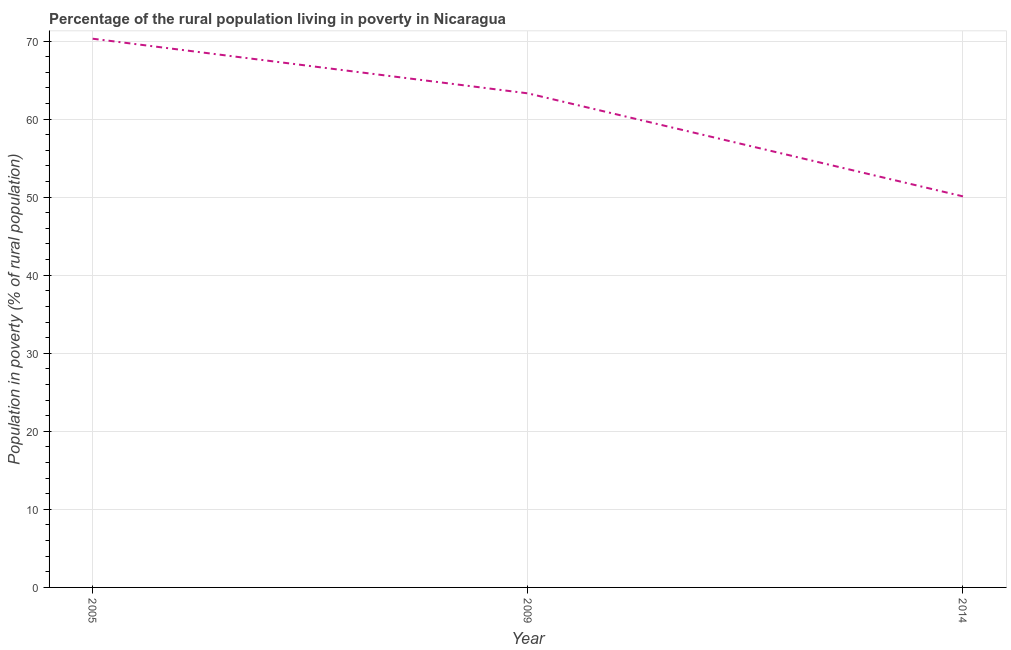What is the percentage of rural population living below poverty line in 2014?
Ensure brevity in your answer.  50.1. Across all years, what is the maximum percentage of rural population living below poverty line?
Your answer should be very brief. 70.3. Across all years, what is the minimum percentage of rural population living below poverty line?
Give a very brief answer. 50.1. In which year was the percentage of rural population living below poverty line minimum?
Keep it short and to the point. 2014. What is the sum of the percentage of rural population living below poverty line?
Provide a short and direct response. 183.7. What is the difference between the percentage of rural population living below poverty line in 2009 and 2014?
Your answer should be compact. 13.2. What is the average percentage of rural population living below poverty line per year?
Your response must be concise. 61.23. What is the median percentage of rural population living below poverty line?
Your answer should be compact. 63.3. Do a majority of the years between 2005 and 2014 (inclusive) have percentage of rural population living below poverty line greater than 60 %?
Your answer should be compact. Yes. What is the ratio of the percentage of rural population living below poverty line in 2005 to that in 2014?
Your answer should be compact. 1.4. Is the percentage of rural population living below poverty line in 2005 less than that in 2014?
Make the answer very short. No. Is the difference between the percentage of rural population living below poverty line in 2005 and 2009 greater than the difference between any two years?
Make the answer very short. No. What is the difference between the highest and the second highest percentage of rural population living below poverty line?
Make the answer very short. 7. Is the sum of the percentage of rural population living below poverty line in 2005 and 2014 greater than the maximum percentage of rural population living below poverty line across all years?
Your answer should be compact. Yes. What is the difference between the highest and the lowest percentage of rural population living below poverty line?
Provide a succinct answer. 20.2. In how many years, is the percentage of rural population living below poverty line greater than the average percentage of rural population living below poverty line taken over all years?
Your answer should be very brief. 2. How many lines are there?
Offer a terse response. 1. How many years are there in the graph?
Offer a very short reply. 3. Does the graph contain any zero values?
Your answer should be compact. No. Does the graph contain grids?
Make the answer very short. Yes. What is the title of the graph?
Your answer should be compact. Percentage of the rural population living in poverty in Nicaragua. What is the label or title of the X-axis?
Keep it short and to the point. Year. What is the label or title of the Y-axis?
Offer a very short reply. Population in poverty (% of rural population). What is the Population in poverty (% of rural population) of 2005?
Your response must be concise. 70.3. What is the Population in poverty (% of rural population) in 2009?
Your answer should be very brief. 63.3. What is the Population in poverty (% of rural population) of 2014?
Offer a terse response. 50.1. What is the difference between the Population in poverty (% of rural population) in 2005 and 2014?
Offer a terse response. 20.2. What is the difference between the Population in poverty (% of rural population) in 2009 and 2014?
Provide a succinct answer. 13.2. What is the ratio of the Population in poverty (% of rural population) in 2005 to that in 2009?
Offer a terse response. 1.11. What is the ratio of the Population in poverty (% of rural population) in 2005 to that in 2014?
Your response must be concise. 1.4. What is the ratio of the Population in poverty (% of rural population) in 2009 to that in 2014?
Ensure brevity in your answer.  1.26. 